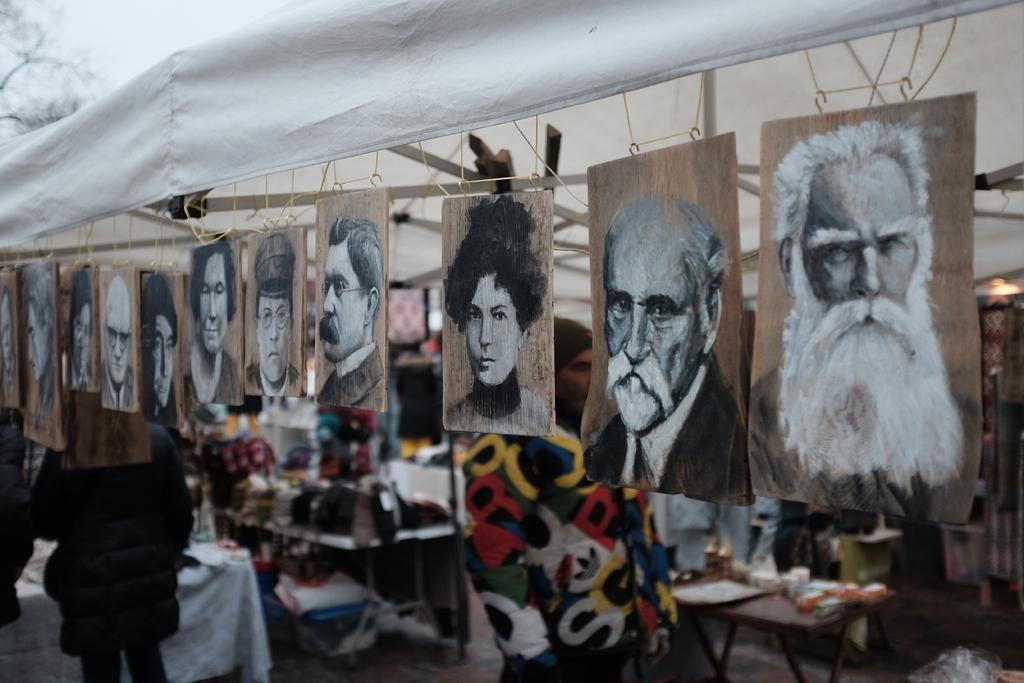Could you give a brief overview of what you see in this image? In this image we can see people, tablecloths, pictures, and few objects. At the top of the image we can see a tent. 